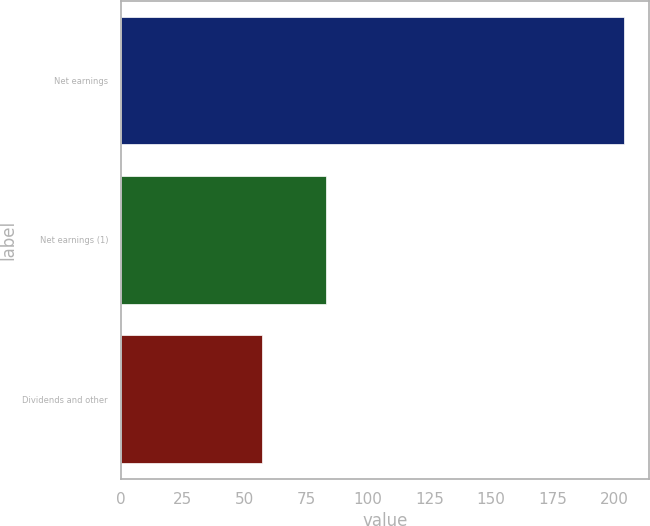<chart> <loc_0><loc_0><loc_500><loc_500><bar_chart><fcel>Net earnings<fcel>Net earnings (1)<fcel>Dividends and other<nl><fcel>204<fcel>83<fcel>57<nl></chart> 